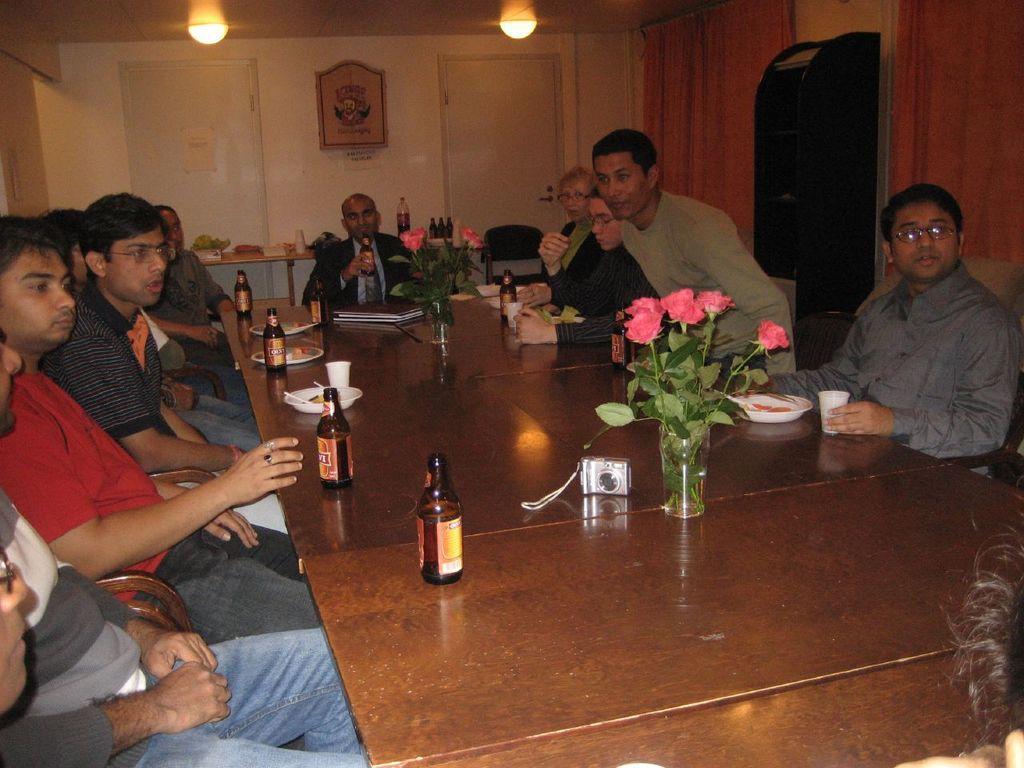Could you give a brief overview of what you see in this image? These group of people are sitting on a chair. In-front of this group of people there is a table, on a table there is a camera, plate, cup, book, flowers and bottles. On top there are lights. This is a rack. These are curtains. This man is holding a bottle. A box on wall. 